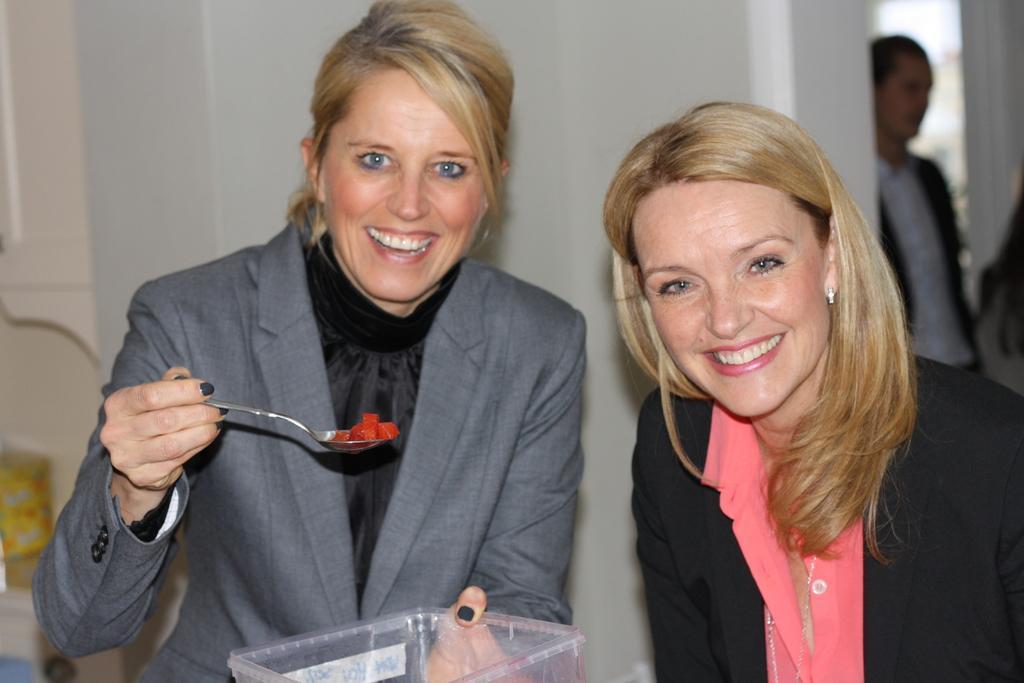Describe this image in one or two sentences. In this image we can see two women standing. In that a woman is holding a spoon and a box. On the backside we can see a person and a wall. 